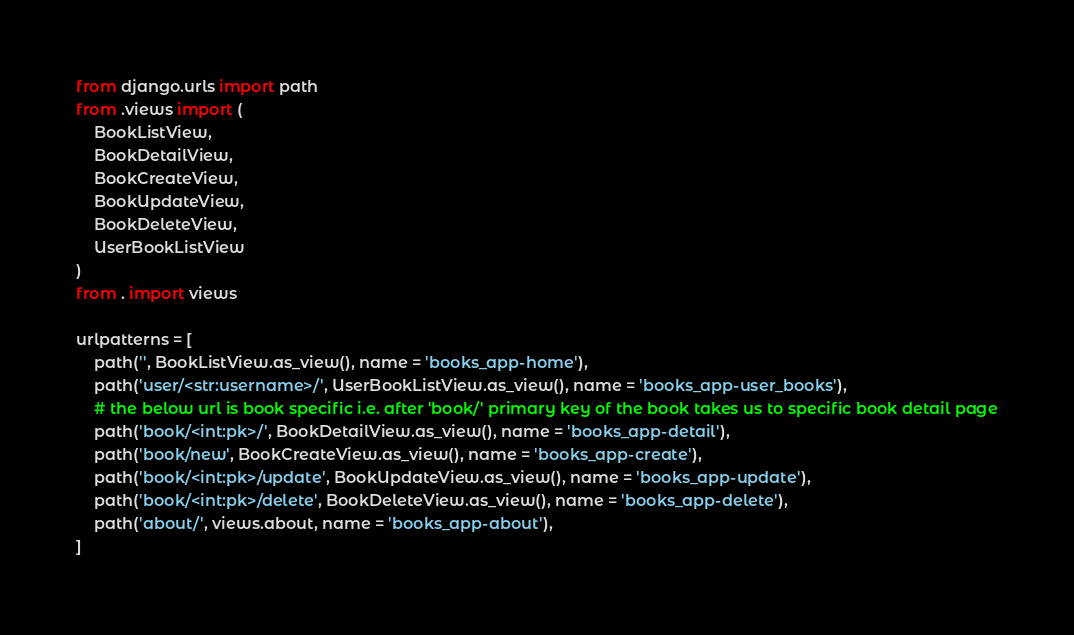Convert code to text. <code><loc_0><loc_0><loc_500><loc_500><_Python_>from django.urls import path
from .views import (
    BookListView,
    BookDetailView,
    BookCreateView,
    BookUpdateView,
    BookDeleteView,
    UserBookListView
)
from . import views

urlpatterns = [
    path('', BookListView.as_view(), name = 'books_app-home'),
    path('user/<str:username>/', UserBookListView.as_view(), name = 'books_app-user_books'),
    # the below url is book specific i.e. after 'book/' primary key of the book takes us to specific book detail page
    path('book/<int:pk>/', BookDetailView.as_view(), name = 'books_app-detail'),
    path('book/new', BookCreateView.as_view(), name = 'books_app-create'),
    path('book/<int:pk>/update', BookUpdateView.as_view(), name = 'books_app-update'),
    path('book/<int:pk>/delete', BookDeleteView.as_view(), name = 'books_app-delete'),
    path('about/', views.about, name = 'books_app-about'),
]
</code> 